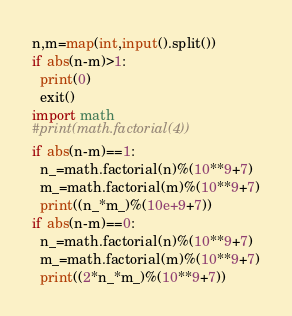Convert code to text. <code><loc_0><loc_0><loc_500><loc_500><_Python_>n,m=map(int,input().split())
if abs(n-m)>1:
  print(0)
  exit()
import math
#print(math.factorial(4))
if abs(n-m)==1:
  n_=math.factorial(n)%(10**9+7)
  m_=math.factorial(m)%(10**9+7)
  print((n_*m_)%(10e+9+7))
if abs(n-m)==0:
  n_=math.factorial(n)%(10**9+7)
  m_=math.factorial(m)%(10**9+7)
  print((2*n_*m_)%(10**9+7))
</code> 